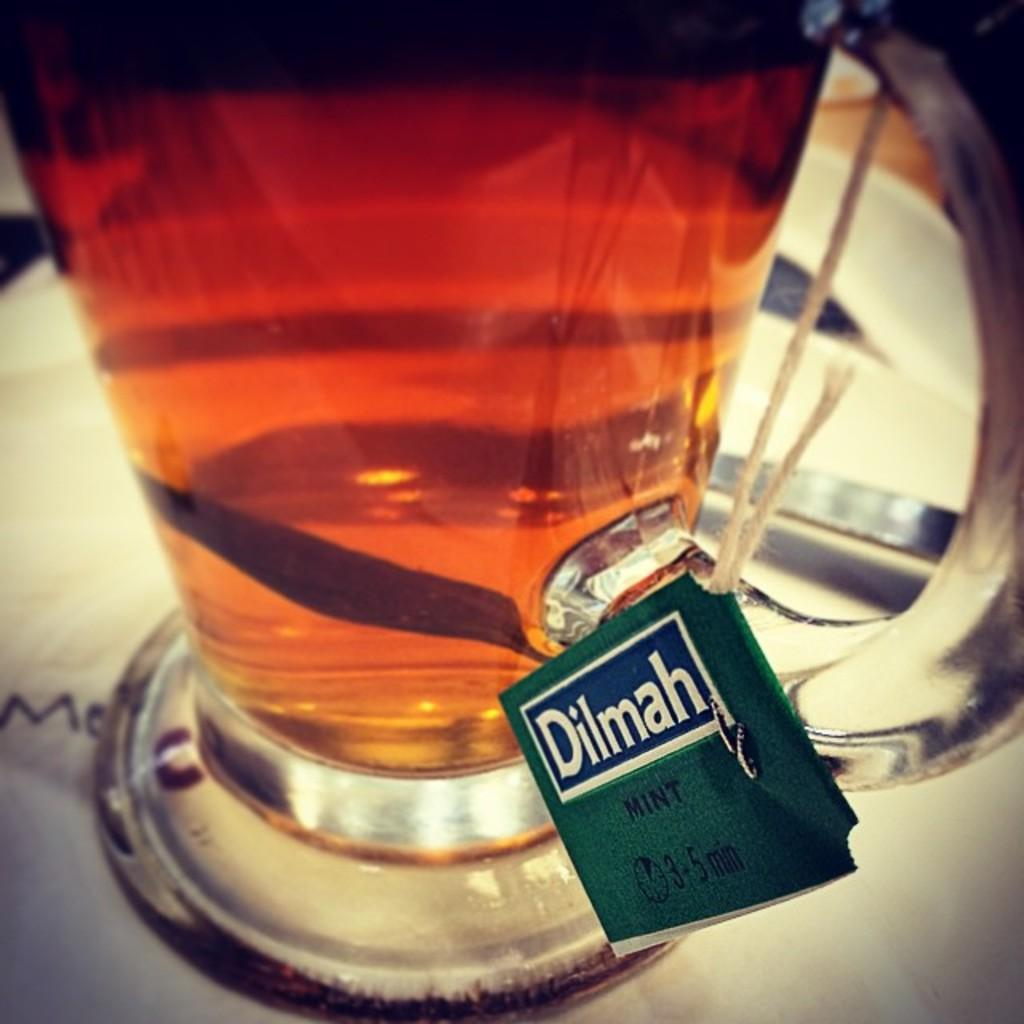<image>
Describe the image concisely. A picher with a tag that reads Dilmah Mint 